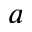<formula> <loc_0><loc_0><loc_500><loc_500>a</formula> 